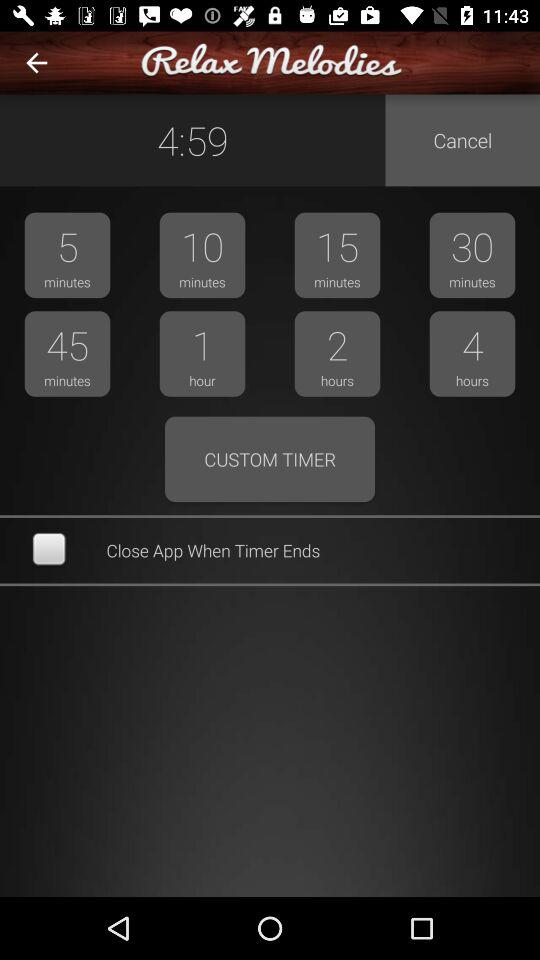What time duration is shown on the screen? The time durations that are shown on the screen are 4 minutes 59 seconds, 5 minutes, 10 minutes, 15 minutes, 30 minutes, 45 minutes, 1 hour, 2 hours and 4 hours. 